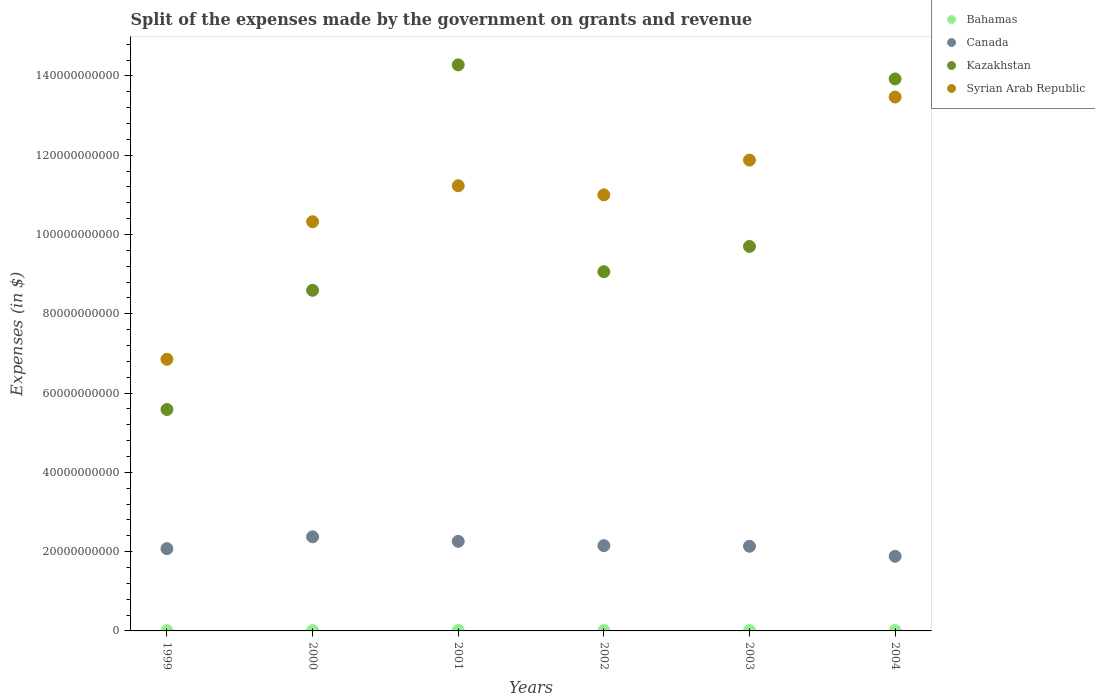How many different coloured dotlines are there?
Your response must be concise. 4. What is the expenses made by the government on grants and revenue in Syrian Arab Republic in 2000?
Offer a very short reply. 1.03e+11. Across all years, what is the maximum expenses made by the government on grants and revenue in Bahamas?
Offer a very short reply. 9.94e+07. Across all years, what is the minimum expenses made by the government on grants and revenue in Bahamas?
Provide a succinct answer. 7.47e+07. What is the total expenses made by the government on grants and revenue in Canada in the graph?
Provide a succinct answer. 1.29e+11. What is the difference between the expenses made by the government on grants and revenue in Bahamas in 2002 and that in 2004?
Ensure brevity in your answer.  -2.30e+06. What is the difference between the expenses made by the government on grants and revenue in Syrian Arab Republic in 2004 and the expenses made by the government on grants and revenue in Bahamas in 2001?
Keep it short and to the point. 1.35e+11. What is the average expenses made by the government on grants and revenue in Kazakhstan per year?
Offer a very short reply. 1.02e+11. In the year 2001, what is the difference between the expenses made by the government on grants and revenue in Kazakhstan and expenses made by the government on grants and revenue in Syrian Arab Republic?
Your answer should be compact. 3.05e+1. In how many years, is the expenses made by the government on grants and revenue in Kazakhstan greater than 36000000000 $?
Give a very brief answer. 6. What is the ratio of the expenses made by the government on grants and revenue in Kazakhstan in 2000 to that in 2001?
Offer a terse response. 0.6. Is the expenses made by the government on grants and revenue in Canada in 1999 less than that in 2002?
Your answer should be very brief. Yes. What is the difference between the highest and the second highest expenses made by the government on grants and revenue in Bahamas?
Your answer should be very brief. 8.70e+06. What is the difference between the highest and the lowest expenses made by the government on grants and revenue in Bahamas?
Offer a terse response. 2.47e+07. In how many years, is the expenses made by the government on grants and revenue in Bahamas greater than the average expenses made by the government on grants and revenue in Bahamas taken over all years?
Offer a very short reply. 3. Is it the case that in every year, the sum of the expenses made by the government on grants and revenue in Bahamas and expenses made by the government on grants and revenue in Syrian Arab Republic  is greater than the sum of expenses made by the government on grants and revenue in Canada and expenses made by the government on grants and revenue in Kazakhstan?
Offer a terse response. No. Is it the case that in every year, the sum of the expenses made by the government on grants and revenue in Kazakhstan and expenses made by the government on grants and revenue in Bahamas  is greater than the expenses made by the government on grants and revenue in Syrian Arab Republic?
Ensure brevity in your answer.  No. Does the expenses made by the government on grants and revenue in Bahamas monotonically increase over the years?
Give a very brief answer. No. Is the expenses made by the government on grants and revenue in Syrian Arab Republic strictly less than the expenses made by the government on grants and revenue in Bahamas over the years?
Ensure brevity in your answer.  No. How many years are there in the graph?
Make the answer very short. 6. Does the graph contain any zero values?
Offer a terse response. No. Does the graph contain grids?
Offer a terse response. No. How many legend labels are there?
Your response must be concise. 4. What is the title of the graph?
Your answer should be compact. Split of the expenses made by the government on grants and revenue. What is the label or title of the Y-axis?
Provide a short and direct response. Expenses (in $). What is the Expenses (in $) of Bahamas in 1999?
Offer a very short reply. 7.51e+07. What is the Expenses (in $) of Canada in 1999?
Your answer should be compact. 2.08e+1. What is the Expenses (in $) in Kazakhstan in 1999?
Your response must be concise. 5.59e+1. What is the Expenses (in $) in Syrian Arab Republic in 1999?
Your answer should be compact. 6.85e+1. What is the Expenses (in $) in Bahamas in 2000?
Your answer should be very brief. 7.47e+07. What is the Expenses (in $) in Canada in 2000?
Keep it short and to the point. 2.37e+1. What is the Expenses (in $) of Kazakhstan in 2000?
Your answer should be very brief. 8.59e+1. What is the Expenses (in $) of Syrian Arab Republic in 2000?
Provide a succinct answer. 1.03e+11. What is the Expenses (in $) in Bahamas in 2001?
Offer a terse response. 9.94e+07. What is the Expenses (in $) in Canada in 2001?
Provide a succinct answer. 2.26e+1. What is the Expenses (in $) of Kazakhstan in 2001?
Your answer should be compact. 1.43e+11. What is the Expenses (in $) in Syrian Arab Republic in 2001?
Your answer should be compact. 1.12e+11. What is the Expenses (in $) in Bahamas in 2002?
Offer a terse response. 8.84e+07. What is the Expenses (in $) in Canada in 2002?
Give a very brief answer. 2.15e+1. What is the Expenses (in $) in Kazakhstan in 2002?
Ensure brevity in your answer.  9.06e+1. What is the Expenses (in $) in Syrian Arab Republic in 2002?
Your answer should be very brief. 1.10e+11. What is the Expenses (in $) in Bahamas in 2003?
Offer a very short reply. 7.72e+07. What is the Expenses (in $) of Canada in 2003?
Make the answer very short. 2.14e+1. What is the Expenses (in $) in Kazakhstan in 2003?
Keep it short and to the point. 9.70e+1. What is the Expenses (in $) in Syrian Arab Republic in 2003?
Keep it short and to the point. 1.19e+11. What is the Expenses (in $) in Bahamas in 2004?
Your response must be concise. 9.07e+07. What is the Expenses (in $) of Canada in 2004?
Offer a terse response. 1.88e+1. What is the Expenses (in $) in Kazakhstan in 2004?
Offer a very short reply. 1.39e+11. What is the Expenses (in $) in Syrian Arab Republic in 2004?
Offer a terse response. 1.35e+11. Across all years, what is the maximum Expenses (in $) in Bahamas?
Your answer should be compact. 9.94e+07. Across all years, what is the maximum Expenses (in $) of Canada?
Offer a very short reply. 2.37e+1. Across all years, what is the maximum Expenses (in $) of Kazakhstan?
Ensure brevity in your answer.  1.43e+11. Across all years, what is the maximum Expenses (in $) of Syrian Arab Republic?
Your answer should be compact. 1.35e+11. Across all years, what is the minimum Expenses (in $) in Bahamas?
Provide a short and direct response. 7.47e+07. Across all years, what is the minimum Expenses (in $) of Canada?
Provide a succinct answer. 1.88e+1. Across all years, what is the minimum Expenses (in $) in Kazakhstan?
Give a very brief answer. 5.59e+1. Across all years, what is the minimum Expenses (in $) of Syrian Arab Republic?
Offer a very short reply. 6.85e+1. What is the total Expenses (in $) in Bahamas in the graph?
Your answer should be very brief. 5.06e+08. What is the total Expenses (in $) in Canada in the graph?
Offer a very short reply. 1.29e+11. What is the total Expenses (in $) of Kazakhstan in the graph?
Your answer should be compact. 6.11e+11. What is the total Expenses (in $) of Syrian Arab Republic in the graph?
Provide a succinct answer. 6.47e+11. What is the difference between the Expenses (in $) of Bahamas in 1999 and that in 2000?
Keep it short and to the point. 4.03e+05. What is the difference between the Expenses (in $) of Canada in 1999 and that in 2000?
Your response must be concise. -2.99e+09. What is the difference between the Expenses (in $) in Kazakhstan in 1999 and that in 2000?
Your answer should be compact. -3.01e+1. What is the difference between the Expenses (in $) in Syrian Arab Republic in 1999 and that in 2000?
Ensure brevity in your answer.  -3.47e+1. What is the difference between the Expenses (in $) in Bahamas in 1999 and that in 2001?
Make the answer very short. -2.43e+07. What is the difference between the Expenses (in $) in Canada in 1999 and that in 2001?
Offer a terse response. -1.84e+09. What is the difference between the Expenses (in $) in Kazakhstan in 1999 and that in 2001?
Offer a very short reply. -8.69e+1. What is the difference between the Expenses (in $) in Syrian Arab Republic in 1999 and that in 2001?
Your answer should be very brief. -4.38e+1. What is the difference between the Expenses (in $) of Bahamas in 1999 and that in 2002?
Offer a very short reply. -1.33e+07. What is the difference between the Expenses (in $) of Canada in 1999 and that in 2002?
Provide a short and direct response. -7.53e+08. What is the difference between the Expenses (in $) of Kazakhstan in 1999 and that in 2002?
Provide a succinct answer. -3.48e+1. What is the difference between the Expenses (in $) in Syrian Arab Republic in 1999 and that in 2002?
Give a very brief answer. -4.15e+1. What is the difference between the Expenses (in $) of Bahamas in 1999 and that in 2003?
Your answer should be very brief. -2.10e+06. What is the difference between the Expenses (in $) in Canada in 1999 and that in 2003?
Ensure brevity in your answer.  -6.05e+08. What is the difference between the Expenses (in $) in Kazakhstan in 1999 and that in 2003?
Your answer should be very brief. -4.11e+1. What is the difference between the Expenses (in $) in Syrian Arab Republic in 1999 and that in 2003?
Keep it short and to the point. -5.02e+1. What is the difference between the Expenses (in $) in Bahamas in 1999 and that in 2004?
Provide a short and direct response. -1.56e+07. What is the difference between the Expenses (in $) of Canada in 1999 and that in 2004?
Offer a very short reply. 1.93e+09. What is the difference between the Expenses (in $) in Kazakhstan in 1999 and that in 2004?
Your answer should be very brief. -8.34e+1. What is the difference between the Expenses (in $) of Syrian Arab Republic in 1999 and that in 2004?
Make the answer very short. -6.62e+1. What is the difference between the Expenses (in $) of Bahamas in 2000 and that in 2001?
Make the answer very short. -2.47e+07. What is the difference between the Expenses (in $) in Canada in 2000 and that in 2001?
Offer a terse response. 1.15e+09. What is the difference between the Expenses (in $) of Kazakhstan in 2000 and that in 2001?
Provide a short and direct response. -5.69e+1. What is the difference between the Expenses (in $) in Syrian Arab Republic in 2000 and that in 2001?
Offer a terse response. -9.07e+09. What is the difference between the Expenses (in $) in Bahamas in 2000 and that in 2002?
Give a very brief answer. -1.37e+07. What is the difference between the Expenses (in $) in Canada in 2000 and that in 2002?
Your answer should be compact. 2.24e+09. What is the difference between the Expenses (in $) of Kazakhstan in 2000 and that in 2002?
Your response must be concise. -4.69e+09. What is the difference between the Expenses (in $) in Syrian Arab Republic in 2000 and that in 2002?
Provide a succinct answer. -6.78e+09. What is the difference between the Expenses (in $) in Bahamas in 2000 and that in 2003?
Offer a terse response. -2.50e+06. What is the difference between the Expenses (in $) of Canada in 2000 and that in 2003?
Offer a very short reply. 2.38e+09. What is the difference between the Expenses (in $) of Kazakhstan in 2000 and that in 2003?
Your answer should be very brief. -1.11e+1. What is the difference between the Expenses (in $) of Syrian Arab Republic in 2000 and that in 2003?
Your answer should be very brief. -1.55e+1. What is the difference between the Expenses (in $) in Bahamas in 2000 and that in 2004?
Provide a succinct answer. -1.60e+07. What is the difference between the Expenses (in $) in Canada in 2000 and that in 2004?
Your answer should be very brief. 4.92e+09. What is the difference between the Expenses (in $) in Kazakhstan in 2000 and that in 2004?
Provide a succinct answer. -5.33e+1. What is the difference between the Expenses (in $) in Syrian Arab Republic in 2000 and that in 2004?
Offer a terse response. -3.15e+1. What is the difference between the Expenses (in $) in Bahamas in 2001 and that in 2002?
Your answer should be very brief. 1.10e+07. What is the difference between the Expenses (in $) of Canada in 2001 and that in 2002?
Offer a very short reply. 1.09e+09. What is the difference between the Expenses (in $) in Kazakhstan in 2001 and that in 2002?
Your answer should be compact. 5.22e+1. What is the difference between the Expenses (in $) of Syrian Arab Republic in 2001 and that in 2002?
Give a very brief answer. 2.29e+09. What is the difference between the Expenses (in $) in Bahamas in 2001 and that in 2003?
Offer a very short reply. 2.22e+07. What is the difference between the Expenses (in $) in Canada in 2001 and that in 2003?
Provide a short and direct response. 1.24e+09. What is the difference between the Expenses (in $) of Kazakhstan in 2001 and that in 2003?
Offer a terse response. 4.58e+1. What is the difference between the Expenses (in $) in Syrian Arab Republic in 2001 and that in 2003?
Your answer should be very brief. -6.47e+09. What is the difference between the Expenses (in $) in Bahamas in 2001 and that in 2004?
Offer a terse response. 8.70e+06. What is the difference between the Expenses (in $) of Canada in 2001 and that in 2004?
Your response must be concise. 3.77e+09. What is the difference between the Expenses (in $) of Kazakhstan in 2001 and that in 2004?
Provide a succinct answer. 3.55e+09. What is the difference between the Expenses (in $) of Syrian Arab Republic in 2001 and that in 2004?
Keep it short and to the point. -2.24e+1. What is the difference between the Expenses (in $) in Bahamas in 2002 and that in 2003?
Your answer should be very brief. 1.12e+07. What is the difference between the Expenses (in $) in Canada in 2002 and that in 2003?
Make the answer very short. 1.48e+08. What is the difference between the Expenses (in $) in Kazakhstan in 2002 and that in 2003?
Make the answer very short. -6.38e+09. What is the difference between the Expenses (in $) of Syrian Arab Republic in 2002 and that in 2003?
Offer a very short reply. -8.76e+09. What is the difference between the Expenses (in $) in Bahamas in 2002 and that in 2004?
Your answer should be compact. -2.30e+06. What is the difference between the Expenses (in $) of Canada in 2002 and that in 2004?
Your answer should be very brief. 2.68e+09. What is the difference between the Expenses (in $) in Kazakhstan in 2002 and that in 2004?
Ensure brevity in your answer.  -4.86e+1. What is the difference between the Expenses (in $) of Syrian Arab Republic in 2002 and that in 2004?
Ensure brevity in your answer.  -2.47e+1. What is the difference between the Expenses (in $) of Bahamas in 2003 and that in 2004?
Ensure brevity in your answer.  -1.35e+07. What is the difference between the Expenses (in $) of Canada in 2003 and that in 2004?
Your answer should be very brief. 2.53e+09. What is the difference between the Expenses (in $) of Kazakhstan in 2003 and that in 2004?
Your answer should be compact. -4.22e+1. What is the difference between the Expenses (in $) in Syrian Arab Republic in 2003 and that in 2004?
Give a very brief answer. -1.59e+1. What is the difference between the Expenses (in $) of Bahamas in 1999 and the Expenses (in $) of Canada in 2000?
Offer a very short reply. -2.37e+1. What is the difference between the Expenses (in $) in Bahamas in 1999 and the Expenses (in $) in Kazakhstan in 2000?
Keep it short and to the point. -8.58e+1. What is the difference between the Expenses (in $) of Bahamas in 1999 and the Expenses (in $) of Syrian Arab Republic in 2000?
Make the answer very short. -1.03e+11. What is the difference between the Expenses (in $) in Canada in 1999 and the Expenses (in $) in Kazakhstan in 2000?
Your answer should be very brief. -6.52e+1. What is the difference between the Expenses (in $) in Canada in 1999 and the Expenses (in $) in Syrian Arab Republic in 2000?
Offer a terse response. -8.25e+1. What is the difference between the Expenses (in $) in Kazakhstan in 1999 and the Expenses (in $) in Syrian Arab Republic in 2000?
Make the answer very short. -4.74e+1. What is the difference between the Expenses (in $) in Bahamas in 1999 and the Expenses (in $) in Canada in 2001?
Ensure brevity in your answer.  -2.25e+1. What is the difference between the Expenses (in $) of Bahamas in 1999 and the Expenses (in $) of Kazakhstan in 2001?
Your answer should be very brief. -1.43e+11. What is the difference between the Expenses (in $) of Bahamas in 1999 and the Expenses (in $) of Syrian Arab Republic in 2001?
Your answer should be very brief. -1.12e+11. What is the difference between the Expenses (in $) in Canada in 1999 and the Expenses (in $) in Kazakhstan in 2001?
Keep it short and to the point. -1.22e+11. What is the difference between the Expenses (in $) in Canada in 1999 and the Expenses (in $) in Syrian Arab Republic in 2001?
Offer a terse response. -9.15e+1. What is the difference between the Expenses (in $) in Kazakhstan in 1999 and the Expenses (in $) in Syrian Arab Republic in 2001?
Provide a short and direct response. -5.64e+1. What is the difference between the Expenses (in $) in Bahamas in 1999 and the Expenses (in $) in Canada in 2002?
Make the answer very short. -2.14e+1. What is the difference between the Expenses (in $) in Bahamas in 1999 and the Expenses (in $) in Kazakhstan in 2002?
Provide a succinct answer. -9.05e+1. What is the difference between the Expenses (in $) of Bahamas in 1999 and the Expenses (in $) of Syrian Arab Republic in 2002?
Offer a very short reply. -1.10e+11. What is the difference between the Expenses (in $) of Canada in 1999 and the Expenses (in $) of Kazakhstan in 2002?
Provide a short and direct response. -6.98e+1. What is the difference between the Expenses (in $) of Canada in 1999 and the Expenses (in $) of Syrian Arab Republic in 2002?
Your answer should be compact. -8.92e+1. What is the difference between the Expenses (in $) of Kazakhstan in 1999 and the Expenses (in $) of Syrian Arab Republic in 2002?
Ensure brevity in your answer.  -5.41e+1. What is the difference between the Expenses (in $) in Bahamas in 1999 and the Expenses (in $) in Canada in 2003?
Provide a succinct answer. -2.13e+1. What is the difference between the Expenses (in $) of Bahamas in 1999 and the Expenses (in $) of Kazakhstan in 2003?
Make the answer very short. -9.69e+1. What is the difference between the Expenses (in $) of Bahamas in 1999 and the Expenses (in $) of Syrian Arab Republic in 2003?
Keep it short and to the point. -1.19e+11. What is the difference between the Expenses (in $) of Canada in 1999 and the Expenses (in $) of Kazakhstan in 2003?
Offer a very short reply. -7.62e+1. What is the difference between the Expenses (in $) in Canada in 1999 and the Expenses (in $) in Syrian Arab Republic in 2003?
Your response must be concise. -9.80e+1. What is the difference between the Expenses (in $) in Kazakhstan in 1999 and the Expenses (in $) in Syrian Arab Republic in 2003?
Give a very brief answer. -6.29e+1. What is the difference between the Expenses (in $) of Bahamas in 1999 and the Expenses (in $) of Canada in 2004?
Offer a terse response. -1.88e+1. What is the difference between the Expenses (in $) of Bahamas in 1999 and the Expenses (in $) of Kazakhstan in 2004?
Give a very brief answer. -1.39e+11. What is the difference between the Expenses (in $) in Bahamas in 1999 and the Expenses (in $) in Syrian Arab Republic in 2004?
Give a very brief answer. -1.35e+11. What is the difference between the Expenses (in $) in Canada in 1999 and the Expenses (in $) in Kazakhstan in 2004?
Offer a very short reply. -1.18e+11. What is the difference between the Expenses (in $) in Canada in 1999 and the Expenses (in $) in Syrian Arab Republic in 2004?
Provide a short and direct response. -1.14e+11. What is the difference between the Expenses (in $) of Kazakhstan in 1999 and the Expenses (in $) of Syrian Arab Republic in 2004?
Your answer should be compact. -7.88e+1. What is the difference between the Expenses (in $) in Bahamas in 2000 and the Expenses (in $) in Canada in 2001?
Give a very brief answer. -2.25e+1. What is the difference between the Expenses (in $) of Bahamas in 2000 and the Expenses (in $) of Kazakhstan in 2001?
Make the answer very short. -1.43e+11. What is the difference between the Expenses (in $) in Bahamas in 2000 and the Expenses (in $) in Syrian Arab Republic in 2001?
Offer a terse response. -1.12e+11. What is the difference between the Expenses (in $) of Canada in 2000 and the Expenses (in $) of Kazakhstan in 2001?
Make the answer very short. -1.19e+11. What is the difference between the Expenses (in $) of Canada in 2000 and the Expenses (in $) of Syrian Arab Republic in 2001?
Offer a very short reply. -8.85e+1. What is the difference between the Expenses (in $) in Kazakhstan in 2000 and the Expenses (in $) in Syrian Arab Republic in 2001?
Give a very brief answer. -2.64e+1. What is the difference between the Expenses (in $) in Bahamas in 2000 and the Expenses (in $) in Canada in 2002?
Keep it short and to the point. -2.14e+1. What is the difference between the Expenses (in $) of Bahamas in 2000 and the Expenses (in $) of Kazakhstan in 2002?
Offer a terse response. -9.05e+1. What is the difference between the Expenses (in $) in Bahamas in 2000 and the Expenses (in $) in Syrian Arab Republic in 2002?
Make the answer very short. -1.10e+11. What is the difference between the Expenses (in $) of Canada in 2000 and the Expenses (in $) of Kazakhstan in 2002?
Your response must be concise. -6.69e+1. What is the difference between the Expenses (in $) in Canada in 2000 and the Expenses (in $) in Syrian Arab Republic in 2002?
Offer a very short reply. -8.62e+1. What is the difference between the Expenses (in $) of Kazakhstan in 2000 and the Expenses (in $) of Syrian Arab Republic in 2002?
Ensure brevity in your answer.  -2.41e+1. What is the difference between the Expenses (in $) in Bahamas in 2000 and the Expenses (in $) in Canada in 2003?
Offer a very short reply. -2.13e+1. What is the difference between the Expenses (in $) in Bahamas in 2000 and the Expenses (in $) in Kazakhstan in 2003?
Keep it short and to the point. -9.69e+1. What is the difference between the Expenses (in $) in Bahamas in 2000 and the Expenses (in $) in Syrian Arab Republic in 2003?
Your answer should be very brief. -1.19e+11. What is the difference between the Expenses (in $) in Canada in 2000 and the Expenses (in $) in Kazakhstan in 2003?
Provide a short and direct response. -7.32e+1. What is the difference between the Expenses (in $) in Canada in 2000 and the Expenses (in $) in Syrian Arab Republic in 2003?
Ensure brevity in your answer.  -9.50e+1. What is the difference between the Expenses (in $) of Kazakhstan in 2000 and the Expenses (in $) of Syrian Arab Republic in 2003?
Provide a short and direct response. -3.28e+1. What is the difference between the Expenses (in $) in Bahamas in 2000 and the Expenses (in $) in Canada in 2004?
Your answer should be compact. -1.88e+1. What is the difference between the Expenses (in $) in Bahamas in 2000 and the Expenses (in $) in Kazakhstan in 2004?
Make the answer very short. -1.39e+11. What is the difference between the Expenses (in $) of Bahamas in 2000 and the Expenses (in $) of Syrian Arab Republic in 2004?
Make the answer very short. -1.35e+11. What is the difference between the Expenses (in $) in Canada in 2000 and the Expenses (in $) in Kazakhstan in 2004?
Provide a short and direct response. -1.15e+11. What is the difference between the Expenses (in $) of Canada in 2000 and the Expenses (in $) of Syrian Arab Republic in 2004?
Your answer should be very brief. -1.11e+11. What is the difference between the Expenses (in $) of Kazakhstan in 2000 and the Expenses (in $) of Syrian Arab Republic in 2004?
Give a very brief answer. -4.87e+1. What is the difference between the Expenses (in $) in Bahamas in 2001 and the Expenses (in $) in Canada in 2002?
Ensure brevity in your answer.  -2.14e+1. What is the difference between the Expenses (in $) of Bahamas in 2001 and the Expenses (in $) of Kazakhstan in 2002?
Make the answer very short. -9.05e+1. What is the difference between the Expenses (in $) in Bahamas in 2001 and the Expenses (in $) in Syrian Arab Republic in 2002?
Provide a succinct answer. -1.10e+11. What is the difference between the Expenses (in $) of Canada in 2001 and the Expenses (in $) of Kazakhstan in 2002?
Your response must be concise. -6.80e+1. What is the difference between the Expenses (in $) of Canada in 2001 and the Expenses (in $) of Syrian Arab Republic in 2002?
Your response must be concise. -8.74e+1. What is the difference between the Expenses (in $) in Kazakhstan in 2001 and the Expenses (in $) in Syrian Arab Republic in 2002?
Offer a terse response. 3.28e+1. What is the difference between the Expenses (in $) in Bahamas in 2001 and the Expenses (in $) in Canada in 2003?
Give a very brief answer. -2.13e+1. What is the difference between the Expenses (in $) of Bahamas in 2001 and the Expenses (in $) of Kazakhstan in 2003?
Provide a succinct answer. -9.69e+1. What is the difference between the Expenses (in $) in Bahamas in 2001 and the Expenses (in $) in Syrian Arab Republic in 2003?
Offer a terse response. -1.19e+11. What is the difference between the Expenses (in $) of Canada in 2001 and the Expenses (in $) of Kazakhstan in 2003?
Offer a very short reply. -7.44e+1. What is the difference between the Expenses (in $) of Canada in 2001 and the Expenses (in $) of Syrian Arab Republic in 2003?
Ensure brevity in your answer.  -9.62e+1. What is the difference between the Expenses (in $) in Kazakhstan in 2001 and the Expenses (in $) in Syrian Arab Republic in 2003?
Your response must be concise. 2.40e+1. What is the difference between the Expenses (in $) of Bahamas in 2001 and the Expenses (in $) of Canada in 2004?
Ensure brevity in your answer.  -1.87e+1. What is the difference between the Expenses (in $) in Bahamas in 2001 and the Expenses (in $) in Kazakhstan in 2004?
Make the answer very short. -1.39e+11. What is the difference between the Expenses (in $) in Bahamas in 2001 and the Expenses (in $) in Syrian Arab Republic in 2004?
Your response must be concise. -1.35e+11. What is the difference between the Expenses (in $) in Canada in 2001 and the Expenses (in $) in Kazakhstan in 2004?
Your answer should be compact. -1.17e+11. What is the difference between the Expenses (in $) of Canada in 2001 and the Expenses (in $) of Syrian Arab Republic in 2004?
Your answer should be compact. -1.12e+11. What is the difference between the Expenses (in $) of Kazakhstan in 2001 and the Expenses (in $) of Syrian Arab Republic in 2004?
Your answer should be very brief. 8.11e+09. What is the difference between the Expenses (in $) of Bahamas in 2002 and the Expenses (in $) of Canada in 2003?
Ensure brevity in your answer.  -2.13e+1. What is the difference between the Expenses (in $) of Bahamas in 2002 and the Expenses (in $) of Kazakhstan in 2003?
Your response must be concise. -9.69e+1. What is the difference between the Expenses (in $) in Bahamas in 2002 and the Expenses (in $) in Syrian Arab Republic in 2003?
Offer a terse response. -1.19e+11. What is the difference between the Expenses (in $) in Canada in 2002 and the Expenses (in $) in Kazakhstan in 2003?
Provide a short and direct response. -7.55e+1. What is the difference between the Expenses (in $) of Canada in 2002 and the Expenses (in $) of Syrian Arab Republic in 2003?
Make the answer very short. -9.72e+1. What is the difference between the Expenses (in $) in Kazakhstan in 2002 and the Expenses (in $) in Syrian Arab Republic in 2003?
Provide a short and direct response. -2.81e+1. What is the difference between the Expenses (in $) in Bahamas in 2002 and the Expenses (in $) in Canada in 2004?
Your answer should be compact. -1.87e+1. What is the difference between the Expenses (in $) of Bahamas in 2002 and the Expenses (in $) of Kazakhstan in 2004?
Provide a succinct answer. -1.39e+11. What is the difference between the Expenses (in $) of Bahamas in 2002 and the Expenses (in $) of Syrian Arab Republic in 2004?
Ensure brevity in your answer.  -1.35e+11. What is the difference between the Expenses (in $) of Canada in 2002 and the Expenses (in $) of Kazakhstan in 2004?
Provide a short and direct response. -1.18e+11. What is the difference between the Expenses (in $) of Canada in 2002 and the Expenses (in $) of Syrian Arab Republic in 2004?
Your answer should be compact. -1.13e+11. What is the difference between the Expenses (in $) of Kazakhstan in 2002 and the Expenses (in $) of Syrian Arab Republic in 2004?
Offer a terse response. -4.41e+1. What is the difference between the Expenses (in $) in Bahamas in 2003 and the Expenses (in $) in Canada in 2004?
Ensure brevity in your answer.  -1.87e+1. What is the difference between the Expenses (in $) in Bahamas in 2003 and the Expenses (in $) in Kazakhstan in 2004?
Give a very brief answer. -1.39e+11. What is the difference between the Expenses (in $) in Bahamas in 2003 and the Expenses (in $) in Syrian Arab Republic in 2004?
Provide a short and direct response. -1.35e+11. What is the difference between the Expenses (in $) of Canada in 2003 and the Expenses (in $) of Kazakhstan in 2004?
Offer a terse response. -1.18e+11. What is the difference between the Expenses (in $) in Canada in 2003 and the Expenses (in $) in Syrian Arab Republic in 2004?
Make the answer very short. -1.13e+11. What is the difference between the Expenses (in $) of Kazakhstan in 2003 and the Expenses (in $) of Syrian Arab Republic in 2004?
Ensure brevity in your answer.  -3.77e+1. What is the average Expenses (in $) in Bahamas per year?
Provide a short and direct response. 8.43e+07. What is the average Expenses (in $) of Canada per year?
Your answer should be compact. 2.15e+1. What is the average Expenses (in $) of Kazakhstan per year?
Your answer should be compact. 1.02e+11. What is the average Expenses (in $) in Syrian Arab Republic per year?
Your answer should be compact. 1.08e+11. In the year 1999, what is the difference between the Expenses (in $) of Bahamas and Expenses (in $) of Canada?
Ensure brevity in your answer.  -2.07e+1. In the year 1999, what is the difference between the Expenses (in $) of Bahamas and Expenses (in $) of Kazakhstan?
Make the answer very short. -5.58e+1. In the year 1999, what is the difference between the Expenses (in $) of Bahamas and Expenses (in $) of Syrian Arab Republic?
Your answer should be compact. -6.84e+1. In the year 1999, what is the difference between the Expenses (in $) in Canada and Expenses (in $) in Kazakhstan?
Your answer should be compact. -3.51e+1. In the year 1999, what is the difference between the Expenses (in $) in Canada and Expenses (in $) in Syrian Arab Republic?
Provide a succinct answer. -4.78e+1. In the year 1999, what is the difference between the Expenses (in $) in Kazakhstan and Expenses (in $) in Syrian Arab Republic?
Make the answer very short. -1.27e+1. In the year 2000, what is the difference between the Expenses (in $) of Bahamas and Expenses (in $) of Canada?
Offer a terse response. -2.37e+1. In the year 2000, what is the difference between the Expenses (in $) of Bahamas and Expenses (in $) of Kazakhstan?
Ensure brevity in your answer.  -8.58e+1. In the year 2000, what is the difference between the Expenses (in $) of Bahamas and Expenses (in $) of Syrian Arab Republic?
Offer a terse response. -1.03e+11. In the year 2000, what is the difference between the Expenses (in $) in Canada and Expenses (in $) in Kazakhstan?
Give a very brief answer. -6.22e+1. In the year 2000, what is the difference between the Expenses (in $) of Canada and Expenses (in $) of Syrian Arab Republic?
Your answer should be very brief. -7.95e+1. In the year 2000, what is the difference between the Expenses (in $) in Kazakhstan and Expenses (in $) in Syrian Arab Republic?
Provide a short and direct response. -1.73e+1. In the year 2001, what is the difference between the Expenses (in $) of Bahamas and Expenses (in $) of Canada?
Your answer should be very brief. -2.25e+1. In the year 2001, what is the difference between the Expenses (in $) of Bahamas and Expenses (in $) of Kazakhstan?
Provide a short and direct response. -1.43e+11. In the year 2001, what is the difference between the Expenses (in $) in Bahamas and Expenses (in $) in Syrian Arab Republic?
Offer a very short reply. -1.12e+11. In the year 2001, what is the difference between the Expenses (in $) of Canada and Expenses (in $) of Kazakhstan?
Make the answer very short. -1.20e+11. In the year 2001, what is the difference between the Expenses (in $) in Canada and Expenses (in $) in Syrian Arab Republic?
Keep it short and to the point. -8.97e+1. In the year 2001, what is the difference between the Expenses (in $) in Kazakhstan and Expenses (in $) in Syrian Arab Republic?
Offer a very short reply. 3.05e+1. In the year 2002, what is the difference between the Expenses (in $) in Bahamas and Expenses (in $) in Canada?
Give a very brief answer. -2.14e+1. In the year 2002, what is the difference between the Expenses (in $) of Bahamas and Expenses (in $) of Kazakhstan?
Ensure brevity in your answer.  -9.05e+1. In the year 2002, what is the difference between the Expenses (in $) in Bahamas and Expenses (in $) in Syrian Arab Republic?
Offer a very short reply. -1.10e+11. In the year 2002, what is the difference between the Expenses (in $) of Canada and Expenses (in $) of Kazakhstan?
Offer a terse response. -6.91e+1. In the year 2002, what is the difference between the Expenses (in $) of Canada and Expenses (in $) of Syrian Arab Republic?
Provide a succinct answer. -8.85e+1. In the year 2002, what is the difference between the Expenses (in $) in Kazakhstan and Expenses (in $) in Syrian Arab Republic?
Your answer should be very brief. -1.94e+1. In the year 2003, what is the difference between the Expenses (in $) in Bahamas and Expenses (in $) in Canada?
Ensure brevity in your answer.  -2.13e+1. In the year 2003, what is the difference between the Expenses (in $) of Bahamas and Expenses (in $) of Kazakhstan?
Your response must be concise. -9.69e+1. In the year 2003, what is the difference between the Expenses (in $) of Bahamas and Expenses (in $) of Syrian Arab Republic?
Offer a terse response. -1.19e+11. In the year 2003, what is the difference between the Expenses (in $) in Canada and Expenses (in $) in Kazakhstan?
Your response must be concise. -7.56e+1. In the year 2003, what is the difference between the Expenses (in $) in Canada and Expenses (in $) in Syrian Arab Republic?
Ensure brevity in your answer.  -9.74e+1. In the year 2003, what is the difference between the Expenses (in $) in Kazakhstan and Expenses (in $) in Syrian Arab Republic?
Provide a succinct answer. -2.18e+1. In the year 2004, what is the difference between the Expenses (in $) in Bahamas and Expenses (in $) in Canada?
Provide a succinct answer. -1.87e+1. In the year 2004, what is the difference between the Expenses (in $) of Bahamas and Expenses (in $) of Kazakhstan?
Keep it short and to the point. -1.39e+11. In the year 2004, what is the difference between the Expenses (in $) in Bahamas and Expenses (in $) in Syrian Arab Republic?
Make the answer very short. -1.35e+11. In the year 2004, what is the difference between the Expenses (in $) of Canada and Expenses (in $) of Kazakhstan?
Offer a terse response. -1.20e+11. In the year 2004, what is the difference between the Expenses (in $) of Canada and Expenses (in $) of Syrian Arab Republic?
Provide a short and direct response. -1.16e+11. In the year 2004, what is the difference between the Expenses (in $) of Kazakhstan and Expenses (in $) of Syrian Arab Republic?
Make the answer very short. 4.56e+09. What is the ratio of the Expenses (in $) of Bahamas in 1999 to that in 2000?
Your answer should be compact. 1.01. What is the ratio of the Expenses (in $) in Canada in 1999 to that in 2000?
Provide a short and direct response. 0.87. What is the ratio of the Expenses (in $) of Kazakhstan in 1999 to that in 2000?
Provide a short and direct response. 0.65. What is the ratio of the Expenses (in $) in Syrian Arab Republic in 1999 to that in 2000?
Your answer should be compact. 0.66. What is the ratio of the Expenses (in $) in Bahamas in 1999 to that in 2001?
Your answer should be compact. 0.76. What is the ratio of the Expenses (in $) in Canada in 1999 to that in 2001?
Keep it short and to the point. 0.92. What is the ratio of the Expenses (in $) of Kazakhstan in 1999 to that in 2001?
Provide a short and direct response. 0.39. What is the ratio of the Expenses (in $) in Syrian Arab Republic in 1999 to that in 2001?
Give a very brief answer. 0.61. What is the ratio of the Expenses (in $) of Bahamas in 1999 to that in 2002?
Make the answer very short. 0.85. What is the ratio of the Expenses (in $) of Kazakhstan in 1999 to that in 2002?
Your answer should be very brief. 0.62. What is the ratio of the Expenses (in $) in Syrian Arab Republic in 1999 to that in 2002?
Your response must be concise. 0.62. What is the ratio of the Expenses (in $) in Bahamas in 1999 to that in 2003?
Make the answer very short. 0.97. What is the ratio of the Expenses (in $) of Canada in 1999 to that in 2003?
Offer a terse response. 0.97. What is the ratio of the Expenses (in $) of Kazakhstan in 1999 to that in 2003?
Keep it short and to the point. 0.58. What is the ratio of the Expenses (in $) of Syrian Arab Republic in 1999 to that in 2003?
Your answer should be very brief. 0.58. What is the ratio of the Expenses (in $) in Bahamas in 1999 to that in 2004?
Your answer should be very brief. 0.83. What is the ratio of the Expenses (in $) in Canada in 1999 to that in 2004?
Give a very brief answer. 1.1. What is the ratio of the Expenses (in $) in Kazakhstan in 1999 to that in 2004?
Offer a terse response. 0.4. What is the ratio of the Expenses (in $) in Syrian Arab Republic in 1999 to that in 2004?
Provide a succinct answer. 0.51. What is the ratio of the Expenses (in $) of Bahamas in 2000 to that in 2001?
Provide a succinct answer. 0.75. What is the ratio of the Expenses (in $) of Canada in 2000 to that in 2001?
Offer a terse response. 1.05. What is the ratio of the Expenses (in $) of Kazakhstan in 2000 to that in 2001?
Ensure brevity in your answer.  0.6. What is the ratio of the Expenses (in $) of Syrian Arab Republic in 2000 to that in 2001?
Provide a succinct answer. 0.92. What is the ratio of the Expenses (in $) of Bahamas in 2000 to that in 2002?
Give a very brief answer. 0.84. What is the ratio of the Expenses (in $) of Canada in 2000 to that in 2002?
Your response must be concise. 1.1. What is the ratio of the Expenses (in $) in Kazakhstan in 2000 to that in 2002?
Give a very brief answer. 0.95. What is the ratio of the Expenses (in $) of Syrian Arab Republic in 2000 to that in 2002?
Give a very brief answer. 0.94. What is the ratio of the Expenses (in $) of Bahamas in 2000 to that in 2003?
Your response must be concise. 0.97. What is the ratio of the Expenses (in $) of Canada in 2000 to that in 2003?
Offer a terse response. 1.11. What is the ratio of the Expenses (in $) of Kazakhstan in 2000 to that in 2003?
Ensure brevity in your answer.  0.89. What is the ratio of the Expenses (in $) in Syrian Arab Republic in 2000 to that in 2003?
Keep it short and to the point. 0.87. What is the ratio of the Expenses (in $) of Bahamas in 2000 to that in 2004?
Provide a short and direct response. 0.82. What is the ratio of the Expenses (in $) of Canada in 2000 to that in 2004?
Your answer should be compact. 1.26. What is the ratio of the Expenses (in $) of Kazakhstan in 2000 to that in 2004?
Your response must be concise. 0.62. What is the ratio of the Expenses (in $) in Syrian Arab Republic in 2000 to that in 2004?
Provide a succinct answer. 0.77. What is the ratio of the Expenses (in $) in Bahamas in 2001 to that in 2002?
Your answer should be compact. 1.12. What is the ratio of the Expenses (in $) of Canada in 2001 to that in 2002?
Your response must be concise. 1.05. What is the ratio of the Expenses (in $) in Kazakhstan in 2001 to that in 2002?
Provide a succinct answer. 1.58. What is the ratio of the Expenses (in $) of Syrian Arab Republic in 2001 to that in 2002?
Offer a very short reply. 1.02. What is the ratio of the Expenses (in $) in Bahamas in 2001 to that in 2003?
Give a very brief answer. 1.29. What is the ratio of the Expenses (in $) of Canada in 2001 to that in 2003?
Your response must be concise. 1.06. What is the ratio of the Expenses (in $) of Kazakhstan in 2001 to that in 2003?
Ensure brevity in your answer.  1.47. What is the ratio of the Expenses (in $) of Syrian Arab Republic in 2001 to that in 2003?
Give a very brief answer. 0.95. What is the ratio of the Expenses (in $) in Bahamas in 2001 to that in 2004?
Provide a succinct answer. 1.1. What is the ratio of the Expenses (in $) in Canada in 2001 to that in 2004?
Provide a short and direct response. 1.2. What is the ratio of the Expenses (in $) in Kazakhstan in 2001 to that in 2004?
Make the answer very short. 1.03. What is the ratio of the Expenses (in $) in Syrian Arab Republic in 2001 to that in 2004?
Provide a short and direct response. 0.83. What is the ratio of the Expenses (in $) in Bahamas in 2002 to that in 2003?
Your answer should be compact. 1.15. What is the ratio of the Expenses (in $) in Kazakhstan in 2002 to that in 2003?
Your answer should be very brief. 0.93. What is the ratio of the Expenses (in $) in Syrian Arab Republic in 2002 to that in 2003?
Keep it short and to the point. 0.93. What is the ratio of the Expenses (in $) in Bahamas in 2002 to that in 2004?
Provide a succinct answer. 0.97. What is the ratio of the Expenses (in $) in Canada in 2002 to that in 2004?
Your answer should be very brief. 1.14. What is the ratio of the Expenses (in $) of Kazakhstan in 2002 to that in 2004?
Offer a terse response. 0.65. What is the ratio of the Expenses (in $) in Syrian Arab Republic in 2002 to that in 2004?
Offer a very short reply. 0.82. What is the ratio of the Expenses (in $) of Bahamas in 2003 to that in 2004?
Keep it short and to the point. 0.85. What is the ratio of the Expenses (in $) of Canada in 2003 to that in 2004?
Offer a very short reply. 1.13. What is the ratio of the Expenses (in $) of Kazakhstan in 2003 to that in 2004?
Provide a succinct answer. 0.7. What is the ratio of the Expenses (in $) of Syrian Arab Republic in 2003 to that in 2004?
Your response must be concise. 0.88. What is the difference between the highest and the second highest Expenses (in $) in Bahamas?
Your answer should be very brief. 8.70e+06. What is the difference between the highest and the second highest Expenses (in $) of Canada?
Make the answer very short. 1.15e+09. What is the difference between the highest and the second highest Expenses (in $) in Kazakhstan?
Your answer should be compact. 3.55e+09. What is the difference between the highest and the second highest Expenses (in $) in Syrian Arab Republic?
Give a very brief answer. 1.59e+1. What is the difference between the highest and the lowest Expenses (in $) in Bahamas?
Provide a short and direct response. 2.47e+07. What is the difference between the highest and the lowest Expenses (in $) of Canada?
Keep it short and to the point. 4.92e+09. What is the difference between the highest and the lowest Expenses (in $) in Kazakhstan?
Your answer should be very brief. 8.69e+1. What is the difference between the highest and the lowest Expenses (in $) in Syrian Arab Republic?
Give a very brief answer. 6.62e+1. 